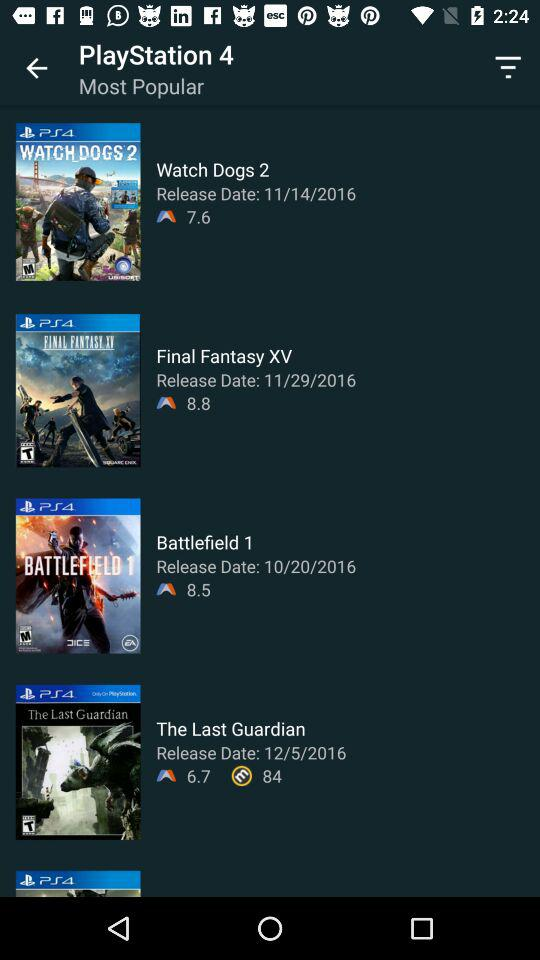Which game has a rating of 6.7? The game that has a rating of 6.7 is "The Last Guardian". 